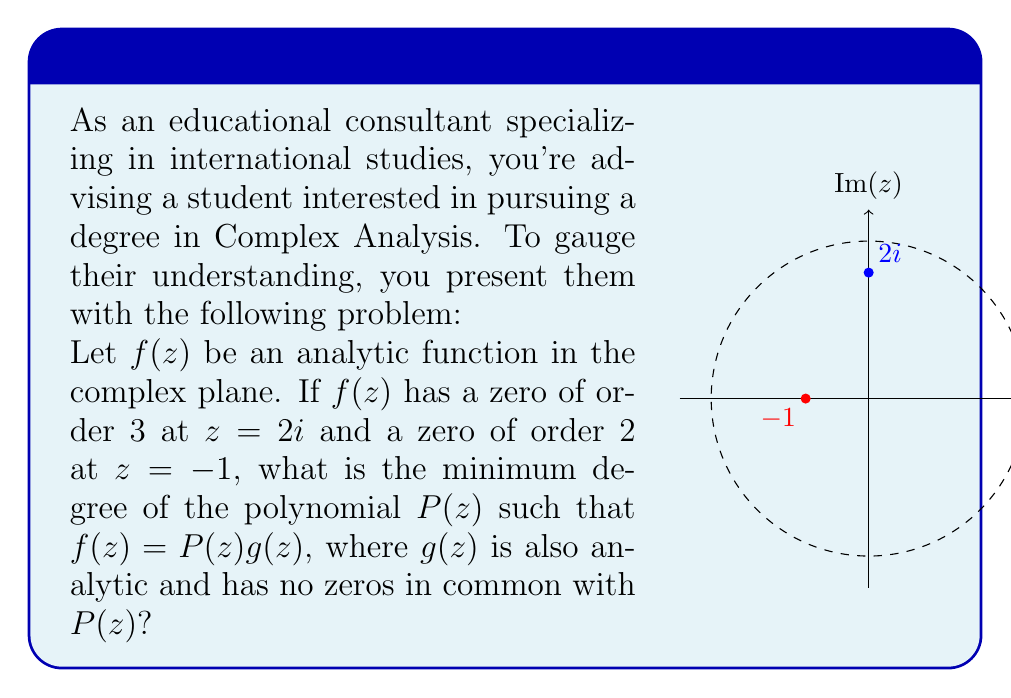What is the answer to this math problem? To solve this problem, we need to understand the properties of analytic functions and their zeros:

1) The order of a zero represents how many times the function or its derivatives equal zero at that point.

2) When we factor an analytic function $f(z)$ into $P(z)g(z)$, the polynomial $P(z)$ captures all the zeros of $f(z)$ along with their orders.

3) The degree of $P(z)$ is the sum of the orders of all zeros of $f(z)$.

Now, let's analyze the given information:

1) $f(z)$ has a zero of order 3 at $z=2i$. This contributes a factor of $(z-2i)^3$ to $P(z)$.

2) $f(z)$ has a zero of order 2 at $z=-1$. This contributes a factor of $(z+1)^2$ to $P(z)$.

3) Therefore, $P(z)$ must be of the form:

   $$P(z) = A(z-2i)^3(z+1)^2$$

   where $A$ is a non-zero constant.

4) The degree of $P(z)$ is the sum of the exponents: $3 + 2 = 5$.

This degree 5 is the minimum possible degree for $P(z)$ that captures all the given zeros of $f(z)$ with their correct orders.
Answer: 5 